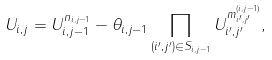<formula> <loc_0><loc_0><loc_500><loc_500>U _ { i , j } = U _ { i , j - 1 } ^ { n _ { i , j - 1 } } - \theta _ { i , j - 1 } \prod _ { ( i ^ { \prime } , j ^ { \prime } ) \in S _ { i , j - 1 } } U _ { i ^ { \prime } , j ^ { \prime } } ^ { m ^ { ( i , j - 1 ) } _ { i ^ { \prime } , j ^ { \prime } } } ,</formula> 